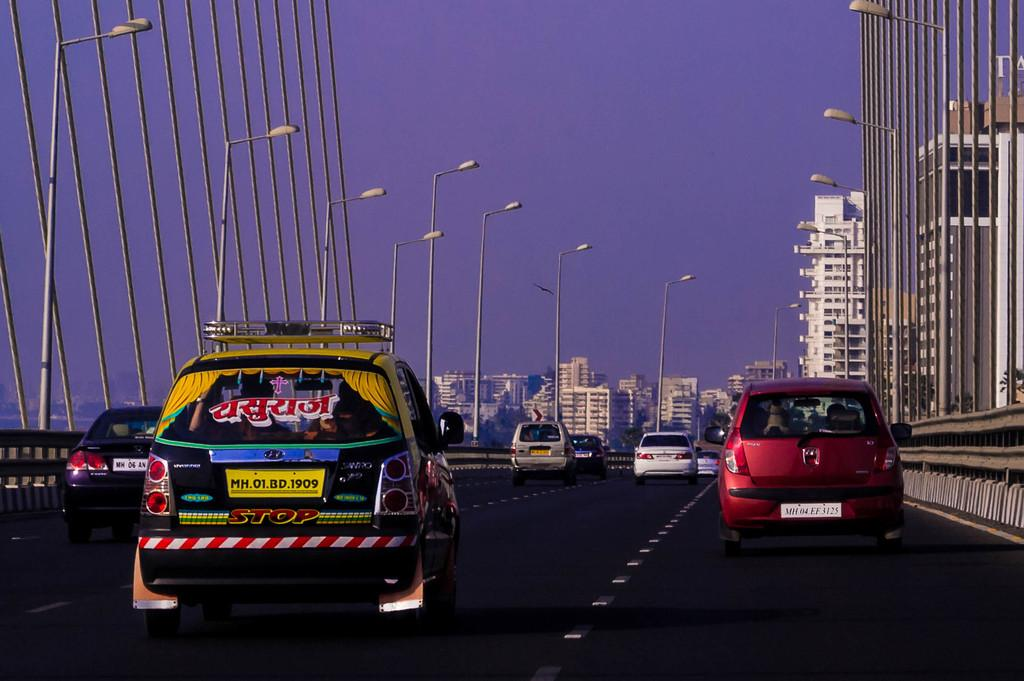What is happening on the road in the image? There are cars moving on the road in the image. What can be seen on the poles in the image? There are lights on the poles in the image. What is visible in the background of the image? There are buildings and the sky visible in the background of the image. Where is the jar of pickles located in the image? There is no jar of pickles present in the image. What type of yard is visible in the image? There is no yard visible in the image; it features a road with cars and poles with lights. 